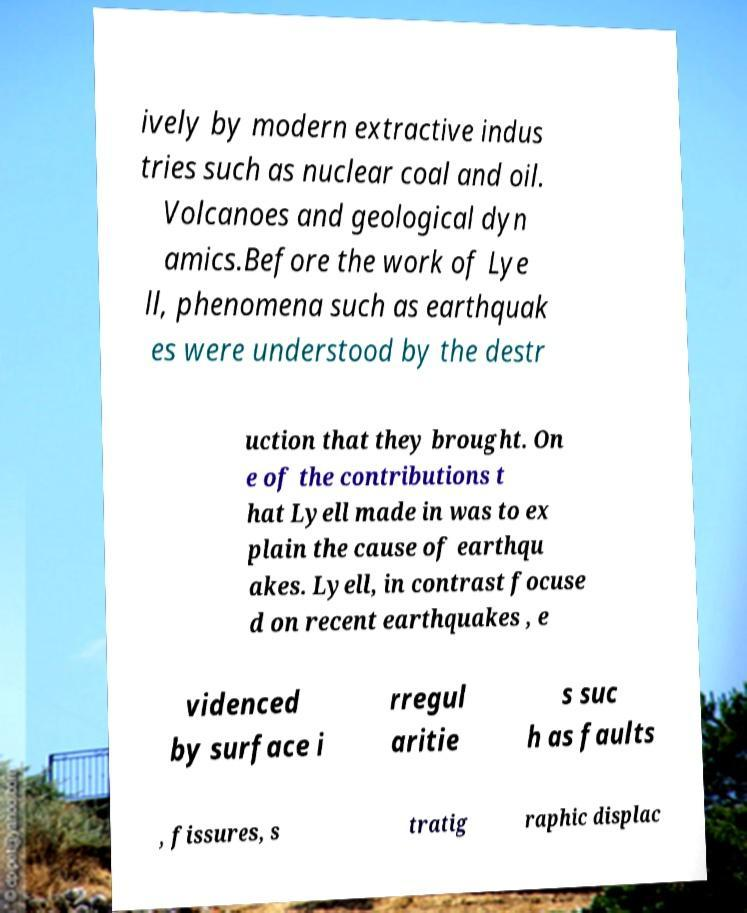What messages or text are displayed in this image? I need them in a readable, typed format. ively by modern extractive indus tries such as nuclear coal and oil. Volcanoes and geological dyn amics.Before the work of Lye ll, phenomena such as earthquak es were understood by the destr uction that they brought. On e of the contributions t hat Lyell made in was to ex plain the cause of earthqu akes. Lyell, in contrast focuse d on recent earthquakes , e videnced by surface i rregul aritie s suc h as faults , fissures, s tratig raphic displac 